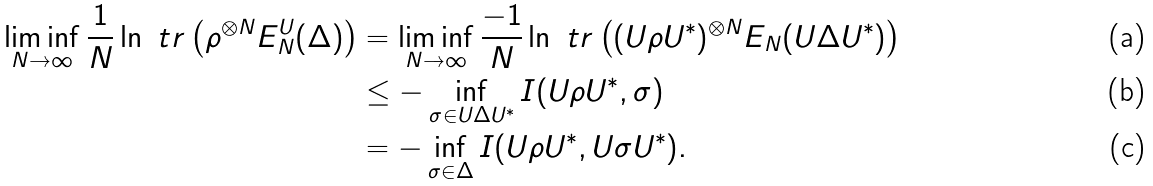Convert formula to latex. <formula><loc_0><loc_0><loc_500><loc_500>\liminf _ { N \to \infty } \frac { 1 } { N } \ln \ t r \left ( \rho ^ { \otimes N } E _ { N } ^ { U } ( \Delta ) \right ) & = \liminf _ { N \to \infty } \frac { - 1 } { N } \ln \ t r \left ( ( U \rho U ^ { * } ) ^ { \otimes N } E _ { N } ( U \Delta U ^ { * } ) \right ) \\ & \leq - \inf _ { \sigma \in U \Delta U ^ { * } } I ( U \rho U ^ { * } , \sigma ) \\ & = - \inf _ { \sigma \in \Delta } I ( U \rho U ^ { * } , U \sigma U ^ { * } ) .</formula> 